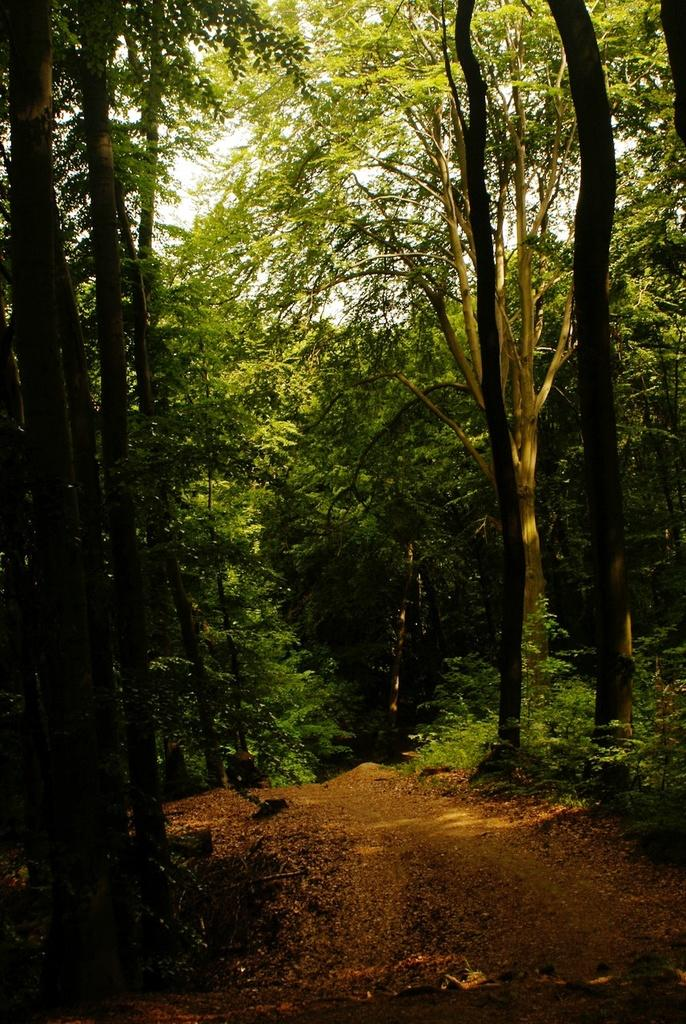What is the main feature of the image? There is a road in the image. What can be seen on the road? Dried leaves are present on the road. What type of vegetation is visible in the background of the image? There are plants and trees in the background of the image. What part of the natural environment is visible in the image? The sky is visible in the background of the image. What type of destruction can be seen caused by the volcano in the image? There is no volcano present in the image, and therefore no destruction can be observed. 